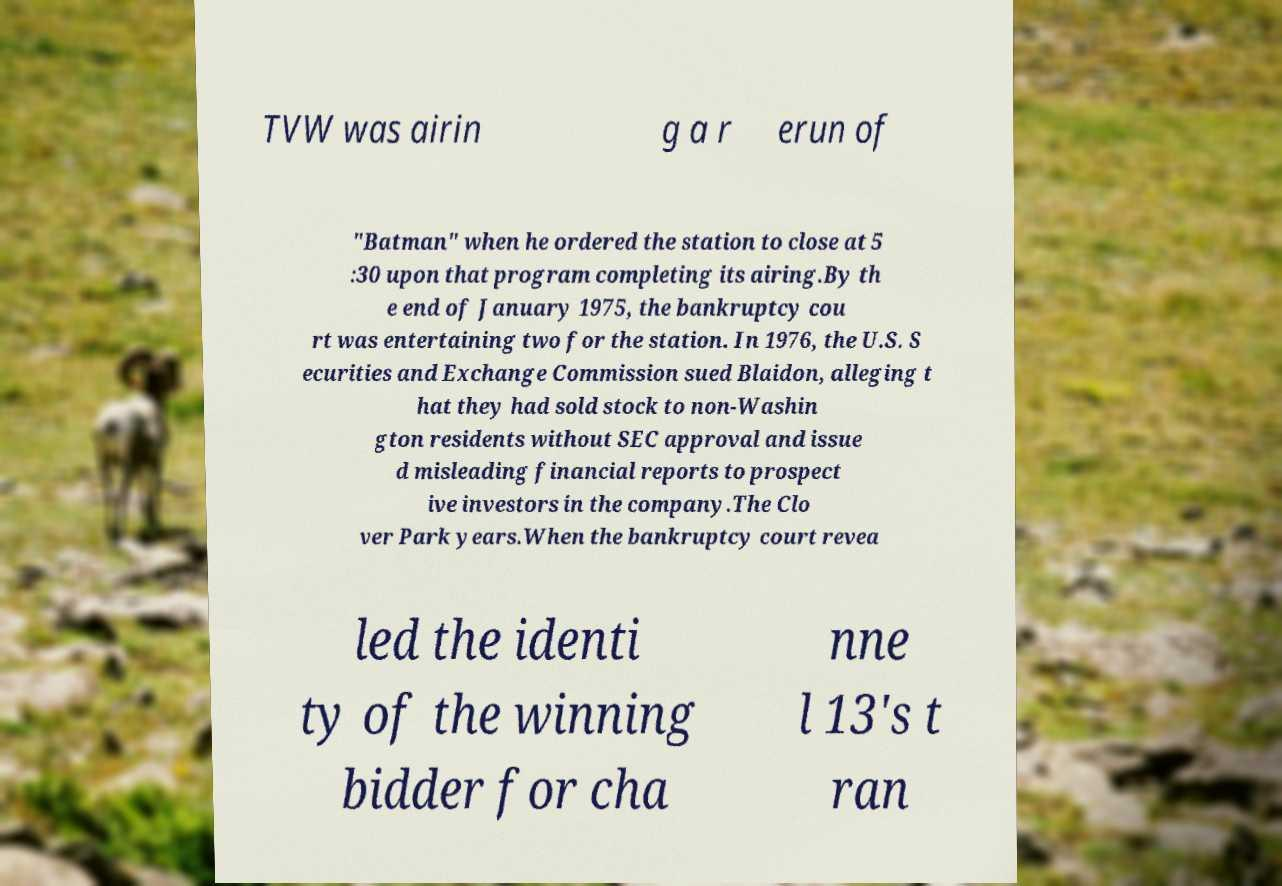There's text embedded in this image that I need extracted. Can you transcribe it verbatim? TVW was airin g a r erun of "Batman" when he ordered the station to close at 5 :30 upon that program completing its airing.By th e end of January 1975, the bankruptcy cou rt was entertaining two for the station. In 1976, the U.S. S ecurities and Exchange Commission sued Blaidon, alleging t hat they had sold stock to non-Washin gton residents without SEC approval and issue d misleading financial reports to prospect ive investors in the company.The Clo ver Park years.When the bankruptcy court revea led the identi ty of the winning bidder for cha nne l 13's t ran 